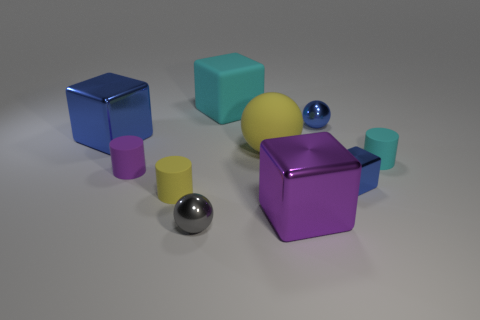Subtract all gray cylinders. How many blue blocks are left? 2 Subtract all purple blocks. How many blocks are left? 3 Subtract all big purple metallic cubes. How many cubes are left? 3 Subtract 1 balls. How many balls are left? 2 Subtract all balls. How many objects are left? 7 Subtract all green cubes. Subtract all brown cylinders. How many cubes are left? 4 Add 3 small blue metallic things. How many small blue metallic things are left? 5 Add 8 purple cylinders. How many purple cylinders exist? 9 Subtract 1 yellow cylinders. How many objects are left? 9 Subtract all yellow spheres. Subtract all yellow things. How many objects are left? 7 